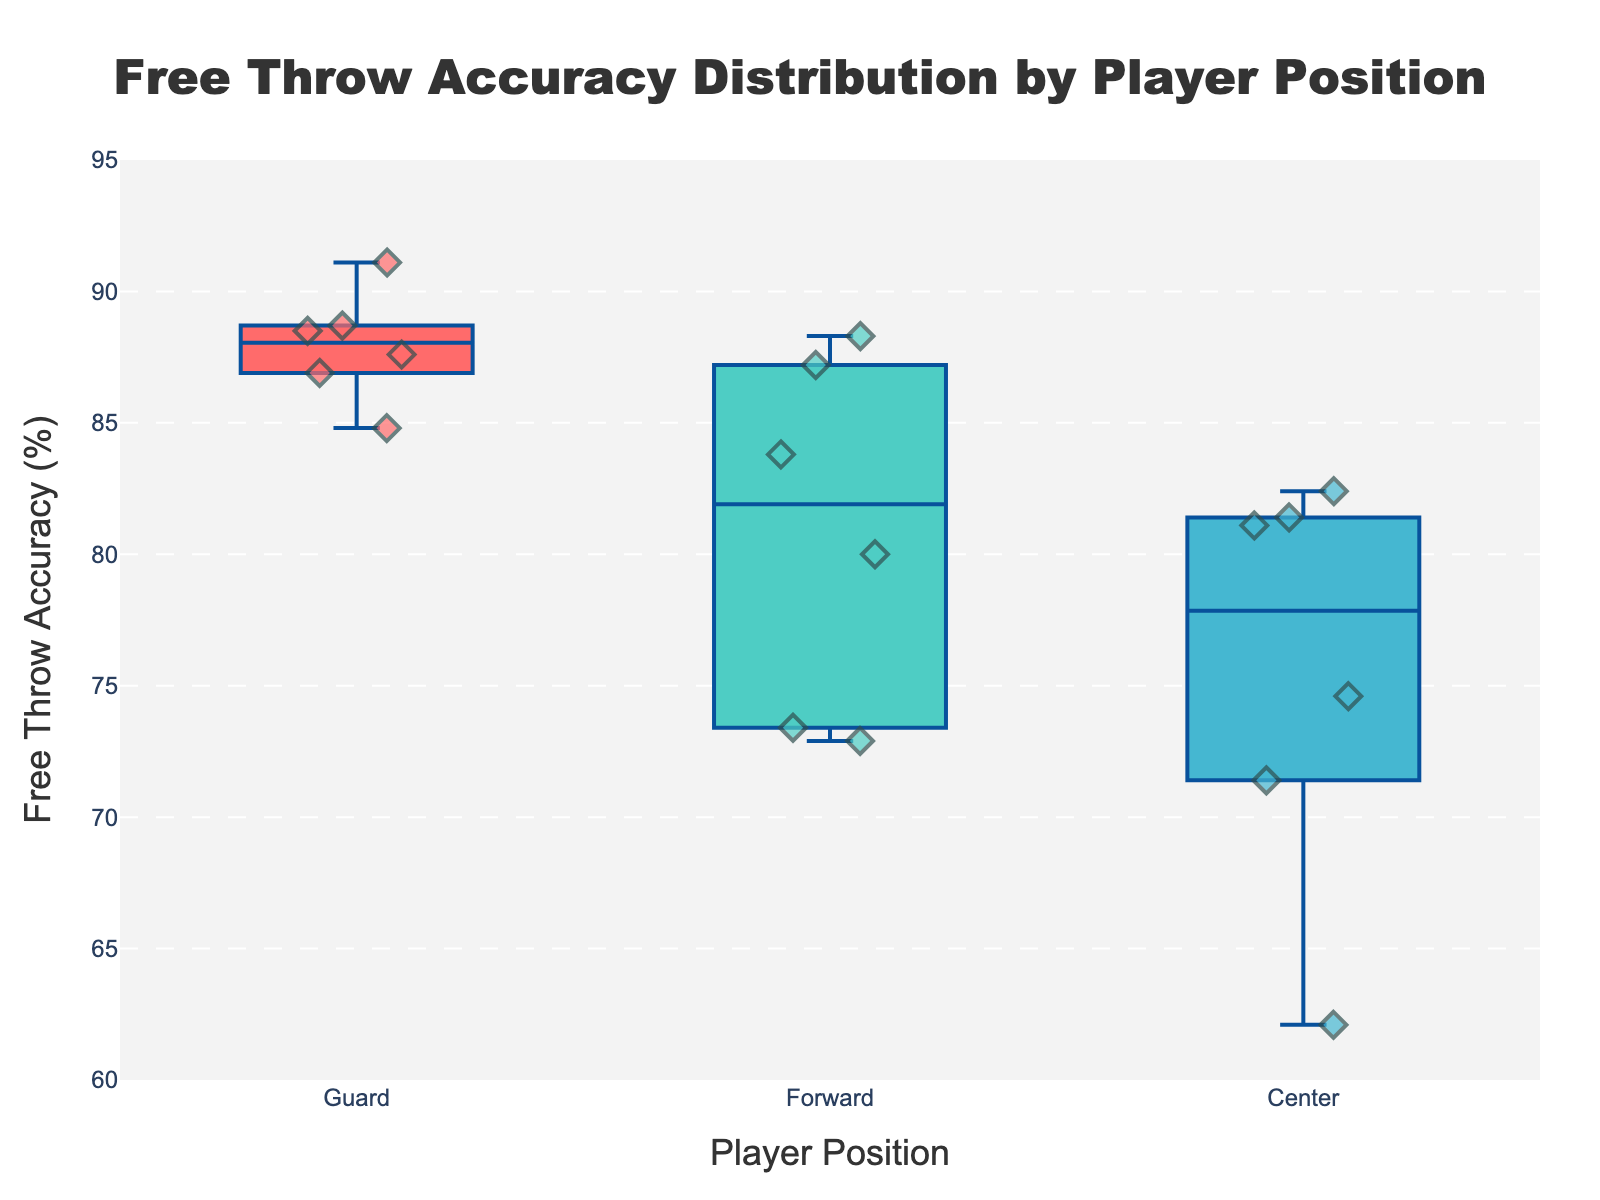What's the title of the figure? The title is usually displayed at the top of the figure. It provides an overview of what the figure is about. In this case, the title is indicated as "Free Throw Accuracy Distribution by Player Position."
Answer: Free Throw Accuracy Distribution by Player Position What is the range of the y-axis? The range of the y-axis indicates the minimum and maximum values that can be seen on the axis. Here, the y-axis range is from 60% to 95% as defined in the layout customization.
Answer: 60% to 95% How many player positions are represented in the figure? The 'Player Position' is shown on the x-axis and the unique positions are mentioned in the code (Guard, Forward, Center).
Answer: Three positions: Guard, Forward, Center Which player position has the highest median free throw accuracy? In a box plot, the median is represented by the line in the middle of the box. Comparing the medians across the three groups (Guards, Forwards, Centers) should give the answer. The Forward group has a noticeably higher median.
Answer: Forwards Which player position has the widest spread in free throw accuracy? The spread in a box plot is indicated by the distance between the minimum and maximum values (the whiskers). By visually comparing the spread, one can notice that Centers have the widest spread as they range from around 62% to above 80%.
Answer: Centers Who has the highest free throw accuracy among all players? Refer to the scatter points to identify the highest single value among all points. Stephen Curry, a Guard, has the highest free throw accuracy at 91.1%.
Answer: Stephen Curry How do the medians of Guards and Centers compare? Look at the medians (central line inside the box). The median for Guards is higher than the median for Centers.
Answer: The median for Guards is higher than Centers Which player has the lowest free throw accuracy and which position does he play? The lowest value among all scatter points should be identified. Rudy Gobert, a Center, has the lowest free throw accuracy at 62.1%.
Answer: Rudy Gobert (Center) What is the interquartile range (IQR) for Forwards? The IQR is the distance between the first quartile (Q1) and the third quartile (Q3). For Forwards, this can be visually approximated by the box's length in the plot. The IQR for Forwards appears to range from roughly 73% to 88%.
Answer: Approximately 15% (from 73% to 88%) How does Klay Thompson's free throw accuracy compare to Kawhi Leonard's? Locate the individual scatter points and check their respective values. Klay Thompson (Guard) has 84.8% while Kawhi Leonard (Forward) has 87.2%. Kawhi Leonard has a higher accuracy.
Answer: Kawhi Leonard has higher accuracy 